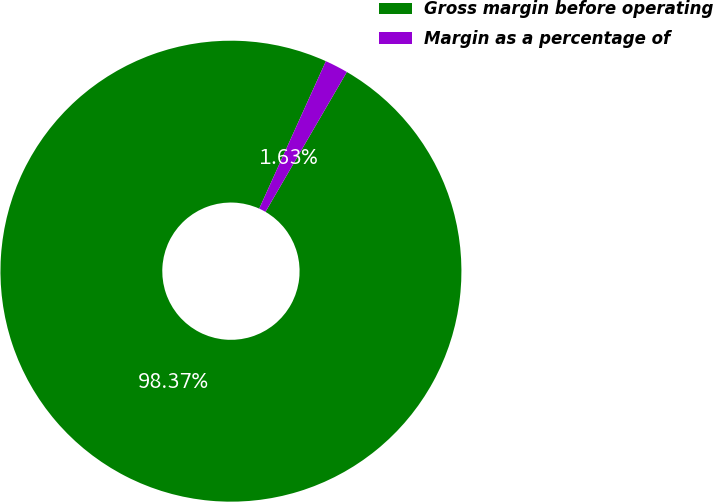Convert chart to OTSL. <chart><loc_0><loc_0><loc_500><loc_500><pie_chart><fcel>Gross margin before operating<fcel>Margin as a percentage of<nl><fcel>98.37%<fcel>1.63%<nl></chart> 